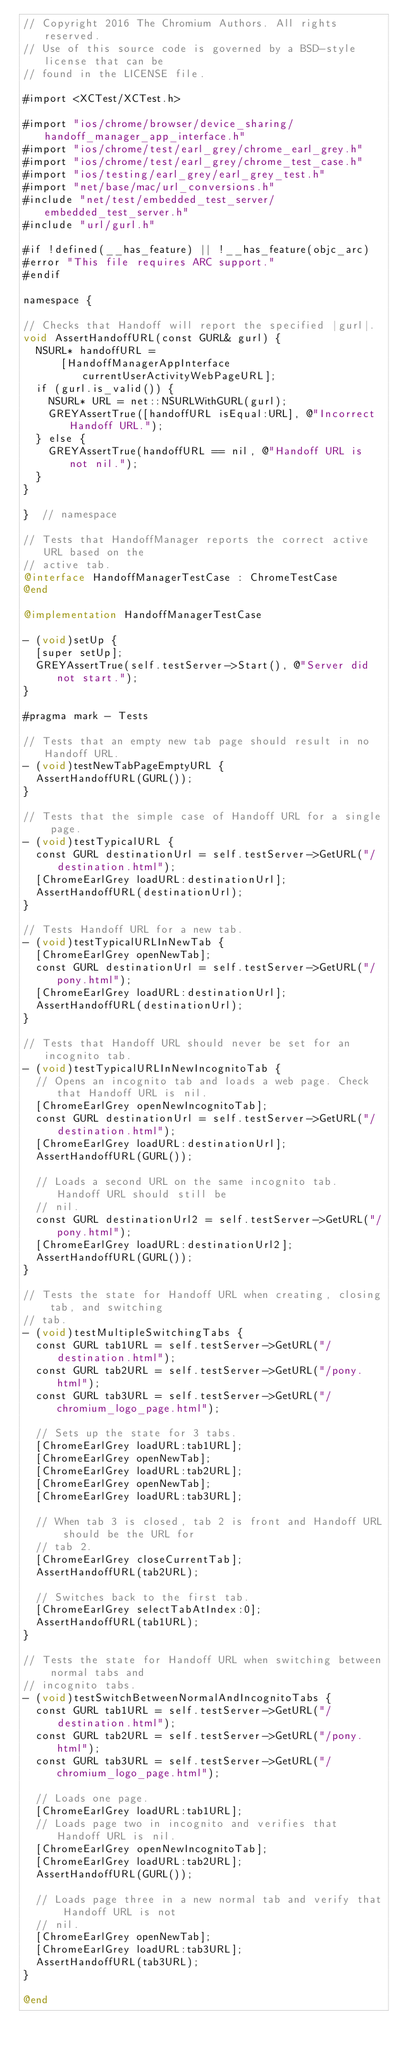<code> <loc_0><loc_0><loc_500><loc_500><_ObjectiveC_>// Copyright 2016 The Chromium Authors. All rights reserved.
// Use of this source code is governed by a BSD-style license that can be
// found in the LICENSE file.

#import <XCTest/XCTest.h>

#import "ios/chrome/browser/device_sharing/handoff_manager_app_interface.h"
#import "ios/chrome/test/earl_grey/chrome_earl_grey.h"
#import "ios/chrome/test/earl_grey/chrome_test_case.h"
#import "ios/testing/earl_grey/earl_grey_test.h"
#import "net/base/mac/url_conversions.h"
#include "net/test/embedded_test_server/embedded_test_server.h"
#include "url/gurl.h"

#if !defined(__has_feature) || !__has_feature(objc_arc)
#error "This file requires ARC support."
#endif

namespace {

// Checks that Handoff will report the specified |gurl|.
void AssertHandoffURL(const GURL& gurl) {
  NSURL* handoffURL =
      [HandoffManagerAppInterface currentUserActivityWebPageURL];
  if (gurl.is_valid()) {
    NSURL* URL = net::NSURLWithGURL(gurl);
    GREYAssertTrue([handoffURL isEqual:URL], @"Incorrect Handoff URL.");
  } else {
    GREYAssertTrue(handoffURL == nil, @"Handoff URL is not nil.");
  }
}

}  // namespace

// Tests that HandoffManager reports the correct active URL based on the
// active tab.
@interface HandoffManagerTestCase : ChromeTestCase
@end

@implementation HandoffManagerTestCase

- (void)setUp {
  [super setUp];
  GREYAssertTrue(self.testServer->Start(), @"Server did not start.");
}

#pragma mark - Tests

// Tests that an empty new tab page should result in no Handoff URL.
- (void)testNewTabPageEmptyURL {
  AssertHandoffURL(GURL());
}

// Tests that the simple case of Handoff URL for a single page.
- (void)testTypicalURL {
  const GURL destinationUrl = self.testServer->GetURL("/destination.html");
  [ChromeEarlGrey loadURL:destinationUrl];
  AssertHandoffURL(destinationUrl);
}

// Tests Handoff URL for a new tab.
- (void)testTypicalURLInNewTab {
  [ChromeEarlGrey openNewTab];
  const GURL destinationUrl = self.testServer->GetURL("/pony.html");
  [ChromeEarlGrey loadURL:destinationUrl];
  AssertHandoffURL(destinationUrl);
}

// Tests that Handoff URL should never be set for an incognito tab.
- (void)testTypicalURLInNewIncognitoTab {
  // Opens an incognito tab and loads a web page. Check that Handoff URL is nil.
  [ChromeEarlGrey openNewIncognitoTab];
  const GURL destinationUrl = self.testServer->GetURL("/destination.html");
  [ChromeEarlGrey loadURL:destinationUrl];
  AssertHandoffURL(GURL());

  // Loads a second URL on the same incognito tab. Handoff URL should still be
  // nil.
  const GURL destinationUrl2 = self.testServer->GetURL("/pony.html");
  [ChromeEarlGrey loadURL:destinationUrl2];
  AssertHandoffURL(GURL());
}

// Tests the state for Handoff URL when creating, closing tab, and switching
// tab.
- (void)testMultipleSwitchingTabs {
  const GURL tab1URL = self.testServer->GetURL("/destination.html");
  const GURL tab2URL = self.testServer->GetURL("/pony.html");
  const GURL tab3URL = self.testServer->GetURL("/chromium_logo_page.html");

  // Sets up the state for 3 tabs.
  [ChromeEarlGrey loadURL:tab1URL];
  [ChromeEarlGrey openNewTab];
  [ChromeEarlGrey loadURL:tab2URL];
  [ChromeEarlGrey openNewTab];
  [ChromeEarlGrey loadURL:tab3URL];

  // When tab 3 is closed, tab 2 is front and Handoff URL should be the URL for
  // tab 2.
  [ChromeEarlGrey closeCurrentTab];
  AssertHandoffURL(tab2URL);

  // Switches back to the first tab.
  [ChromeEarlGrey selectTabAtIndex:0];
  AssertHandoffURL(tab1URL);
}

// Tests the state for Handoff URL when switching between normal tabs and
// incognito tabs.
- (void)testSwitchBetweenNormalAndIncognitoTabs {
  const GURL tab1URL = self.testServer->GetURL("/destination.html");
  const GURL tab2URL = self.testServer->GetURL("/pony.html");
  const GURL tab3URL = self.testServer->GetURL("/chromium_logo_page.html");

  // Loads one page.
  [ChromeEarlGrey loadURL:tab1URL];
  // Loads page two in incognito and verifies that Handoff URL is nil.
  [ChromeEarlGrey openNewIncognitoTab];
  [ChromeEarlGrey loadURL:tab2URL];
  AssertHandoffURL(GURL());

  // Loads page three in a new normal tab and verify that Handoff URL is not
  // nil.
  [ChromeEarlGrey openNewTab];
  [ChromeEarlGrey loadURL:tab3URL];
  AssertHandoffURL(tab3URL);
}

@end
</code> 